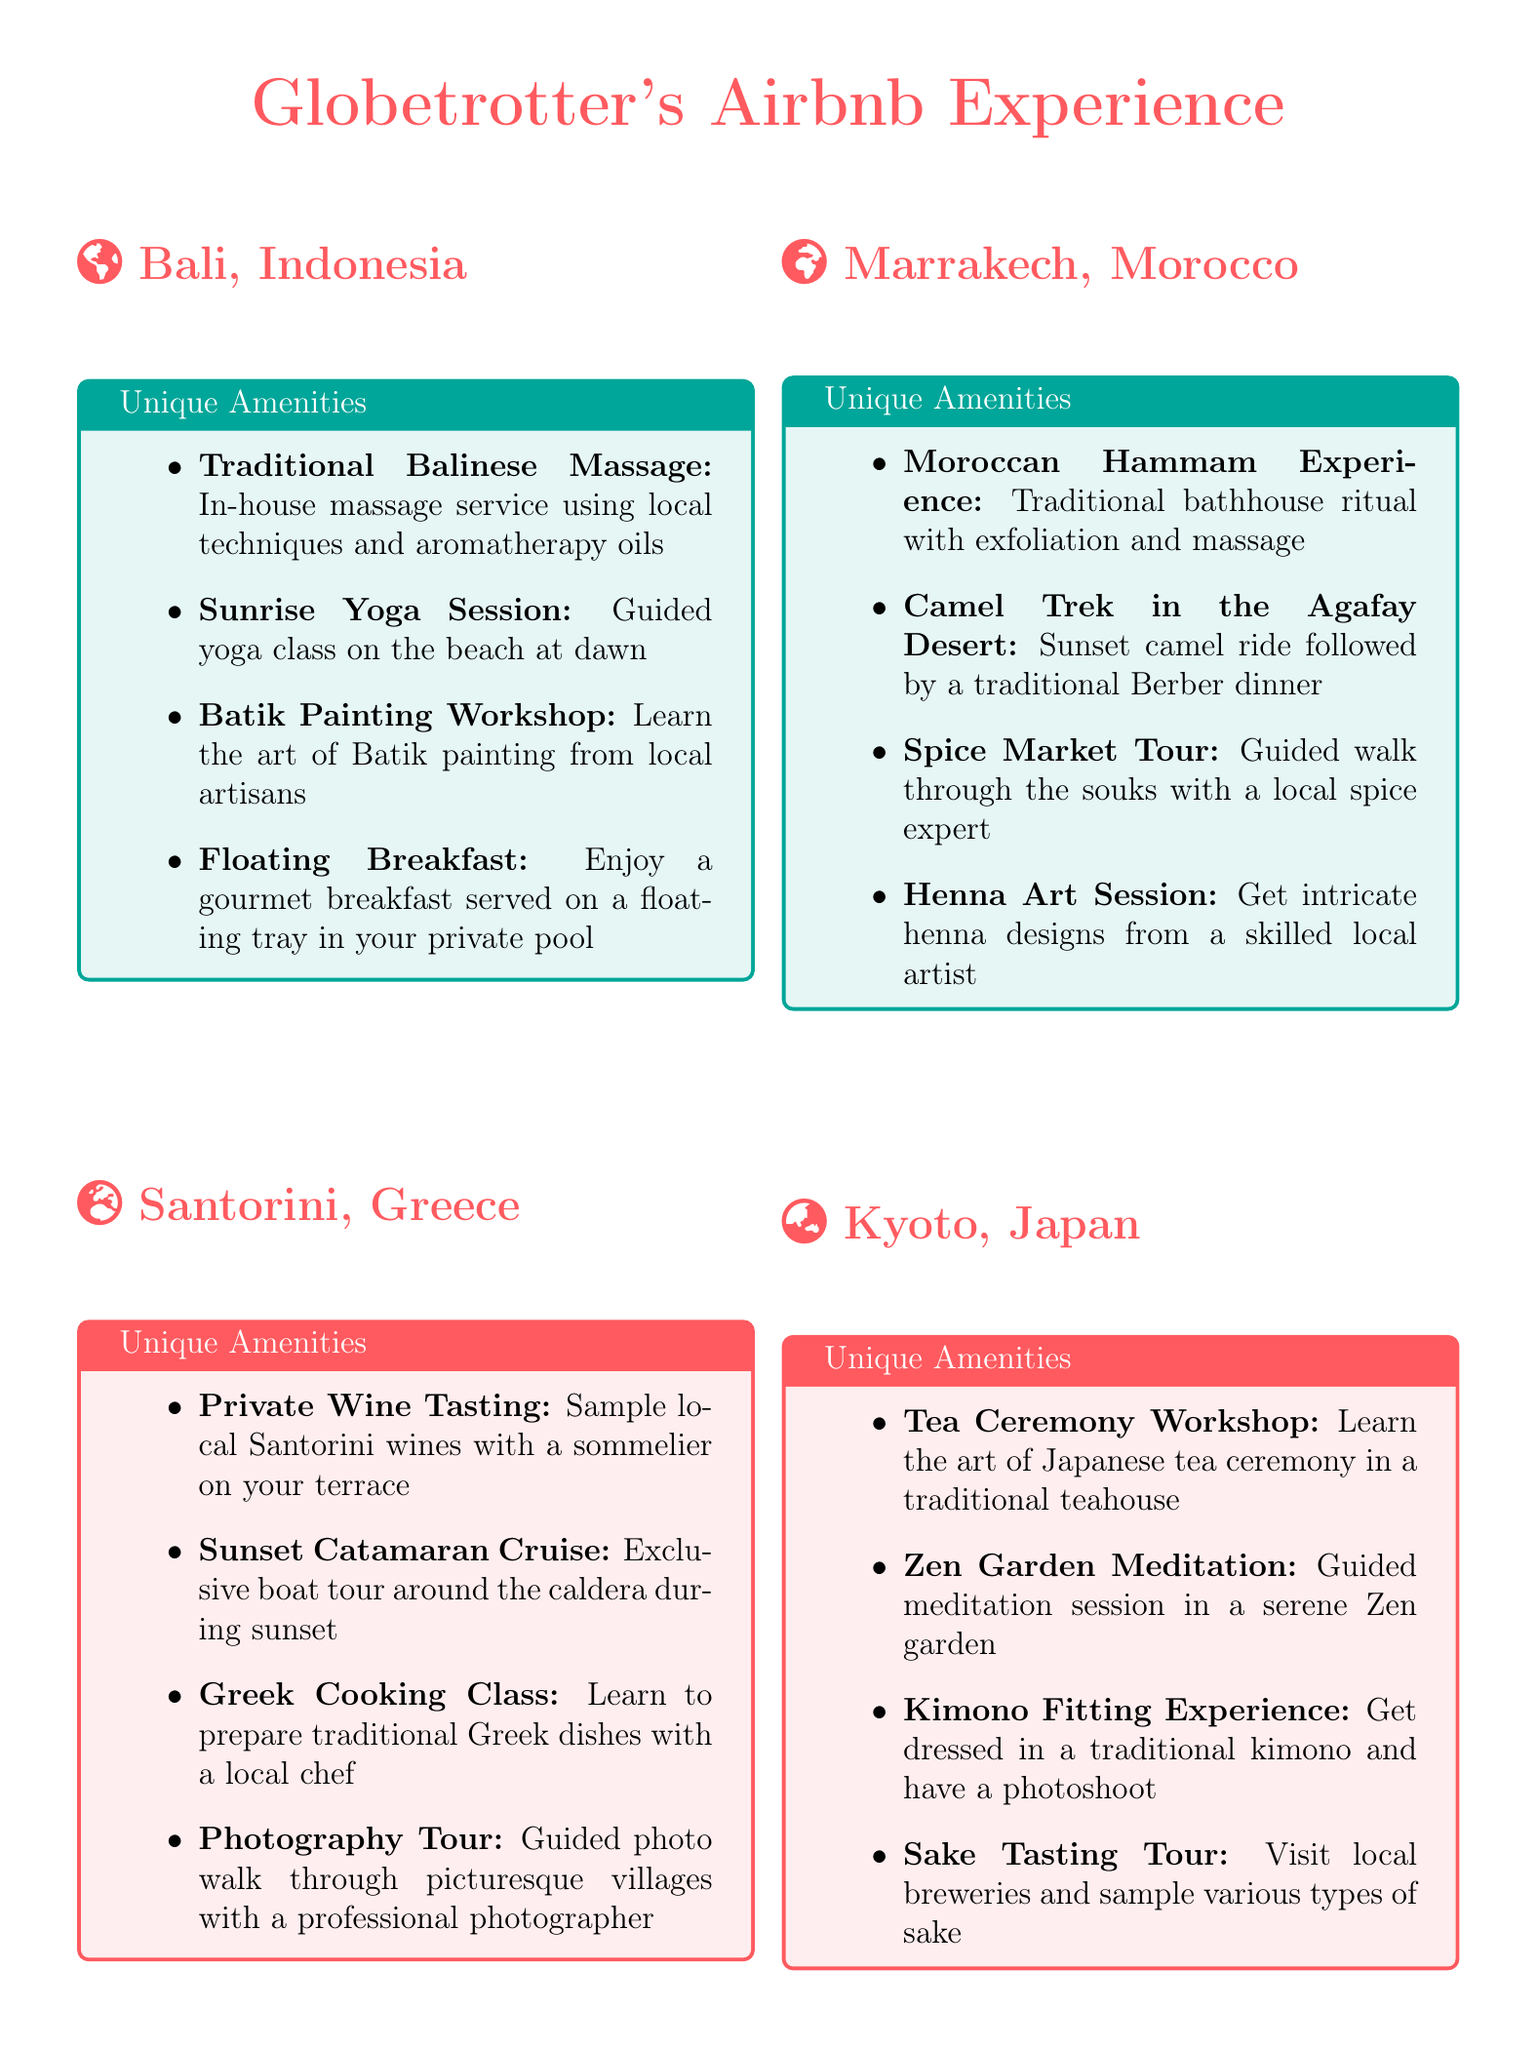what unique amenity is offered in Bali, Indonesia? The document lists several unique amenities for Bali, Indonesia, including the Traditional Balinese Massage.
Answer: Traditional Balinese Massage how many unique amenities are listed for Santorini, Greece? The document provides a list of unique amenities for each location, stating there are four for Santorini.
Answer: 4 name one activity guests can participate in Marrakech, Morocco. The document mentions activities in Marrakech, including the Moroccan Hammam Experience.
Answer: Moroccan Hammam Experience which location offers a Sunset Catamaran Cruise? The amenities listed indicate that the Sunset Catamaran Cruise is specifically offered in Santorini, Greece.
Answer: Santorini, Greece what type of workshop is available in Kyoto, Japan? The document specifies that there is a Tea Ceremony Workshop available in Kyoto, Japan.
Answer: Tea Ceremony Workshop which amenity includes a traditional chocolate ritual in Tulum, Mexico? The document mentions the Mayan Cacao Ceremony as a unique amenity in Tulum.
Answer: Mayan Cacao Ceremony how many locations have unique amenities for beach-related activities? By reviewing the document, we can identify Bali and Tulum as locations with amenities related to beaches, which totals two.
Answer: 2 which unique amenity involves guided meditation? The Zen Garden Meditation is highlighted as a unique amenity that involves guided meditation in Kyoto.
Answer: Zen Garden Meditation what kind of class is offered in Santorini? The document states that a Greek Cooking Class is offered as one of the unique amenities in Santorini.
Answer: Greek Cooking Class 